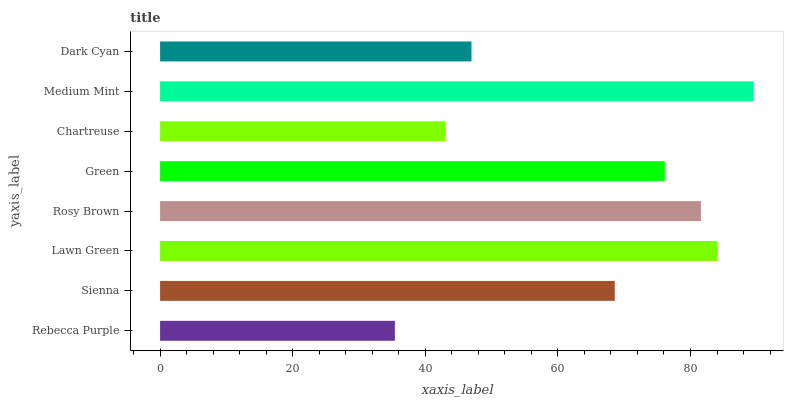Is Rebecca Purple the minimum?
Answer yes or no. Yes. Is Medium Mint the maximum?
Answer yes or no. Yes. Is Sienna the minimum?
Answer yes or no. No. Is Sienna the maximum?
Answer yes or no. No. Is Sienna greater than Rebecca Purple?
Answer yes or no. Yes. Is Rebecca Purple less than Sienna?
Answer yes or no. Yes. Is Rebecca Purple greater than Sienna?
Answer yes or no. No. Is Sienna less than Rebecca Purple?
Answer yes or no. No. Is Green the high median?
Answer yes or no. Yes. Is Sienna the low median?
Answer yes or no. Yes. Is Rebecca Purple the high median?
Answer yes or no. No. Is Green the low median?
Answer yes or no. No. 